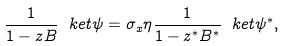<formula> <loc_0><loc_0><loc_500><loc_500>\frac { 1 } { 1 - z B } \ k e t { \psi } = \sigma _ { x } \eta \frac { 1 } { 1 - z ^ { * } B ^ { * } } \ k e t { \psi ^ { * } } ,</formula> 